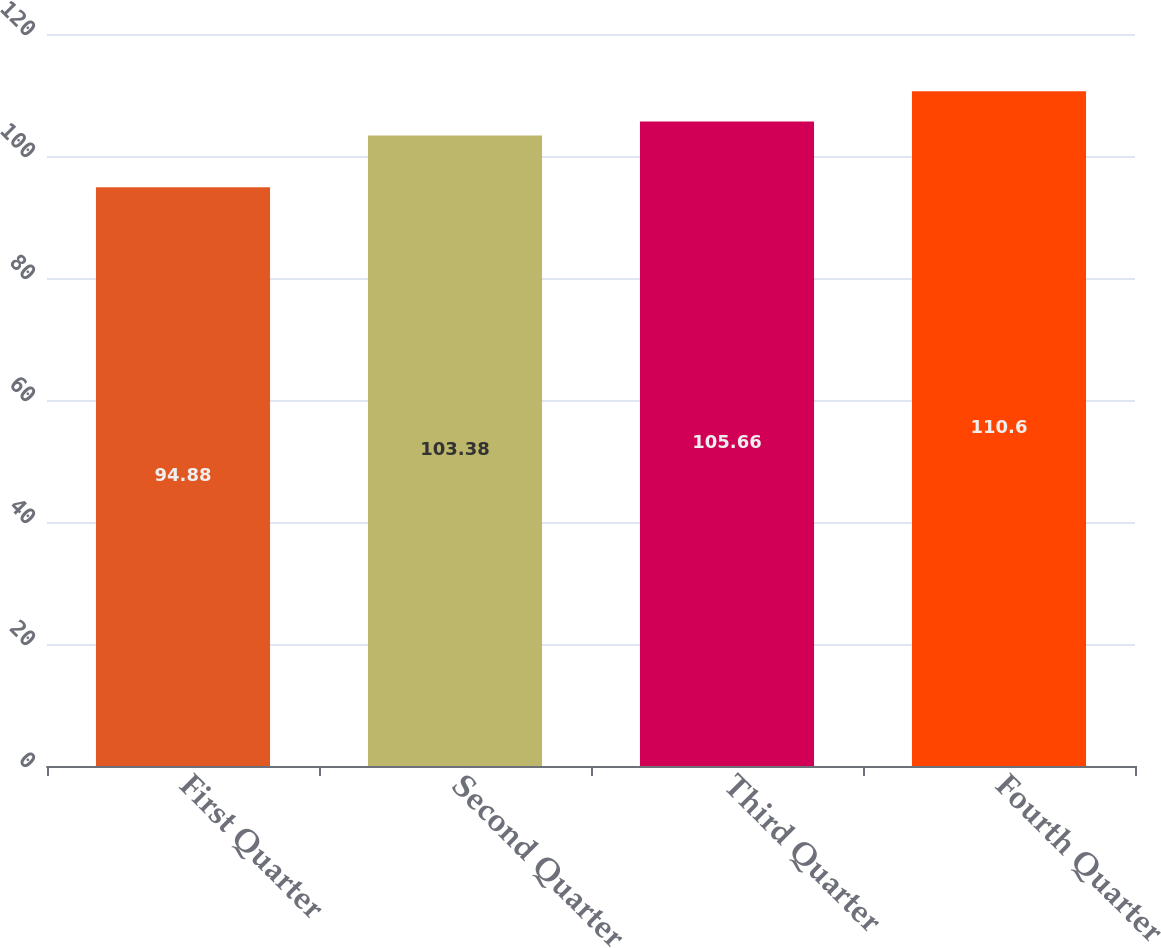Convert chart to OTSL. <chart><loc_0><loc_0><loc_500><loc_500><bar_chart><fcel>First Quarter<fcel>Second Quarter<fcel>Third Quarter<fcel>Fourth Quarter<nl><fcel>94.88<fcel>103.38<fcel>105.66<fcel>110.6<nl></chart> 